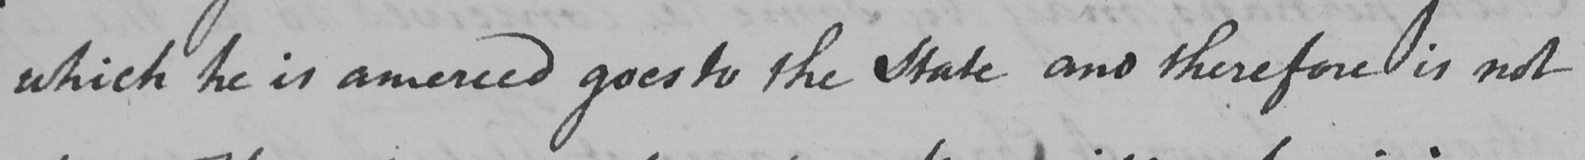Transcribe the text shown in this historical manuscript line. which he is amerced goes to the State and therefore is not 